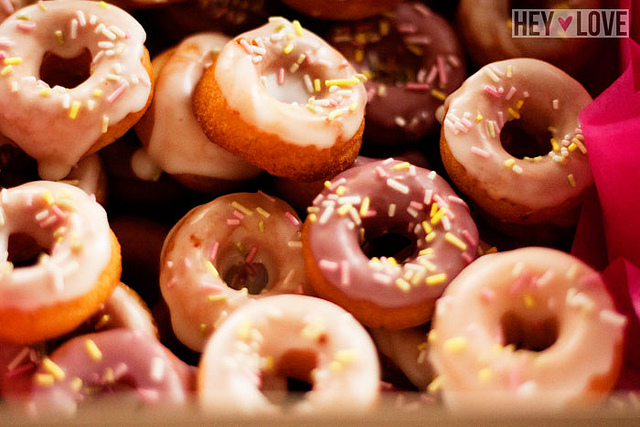Please extract the text content from this image. HEY LOVE 